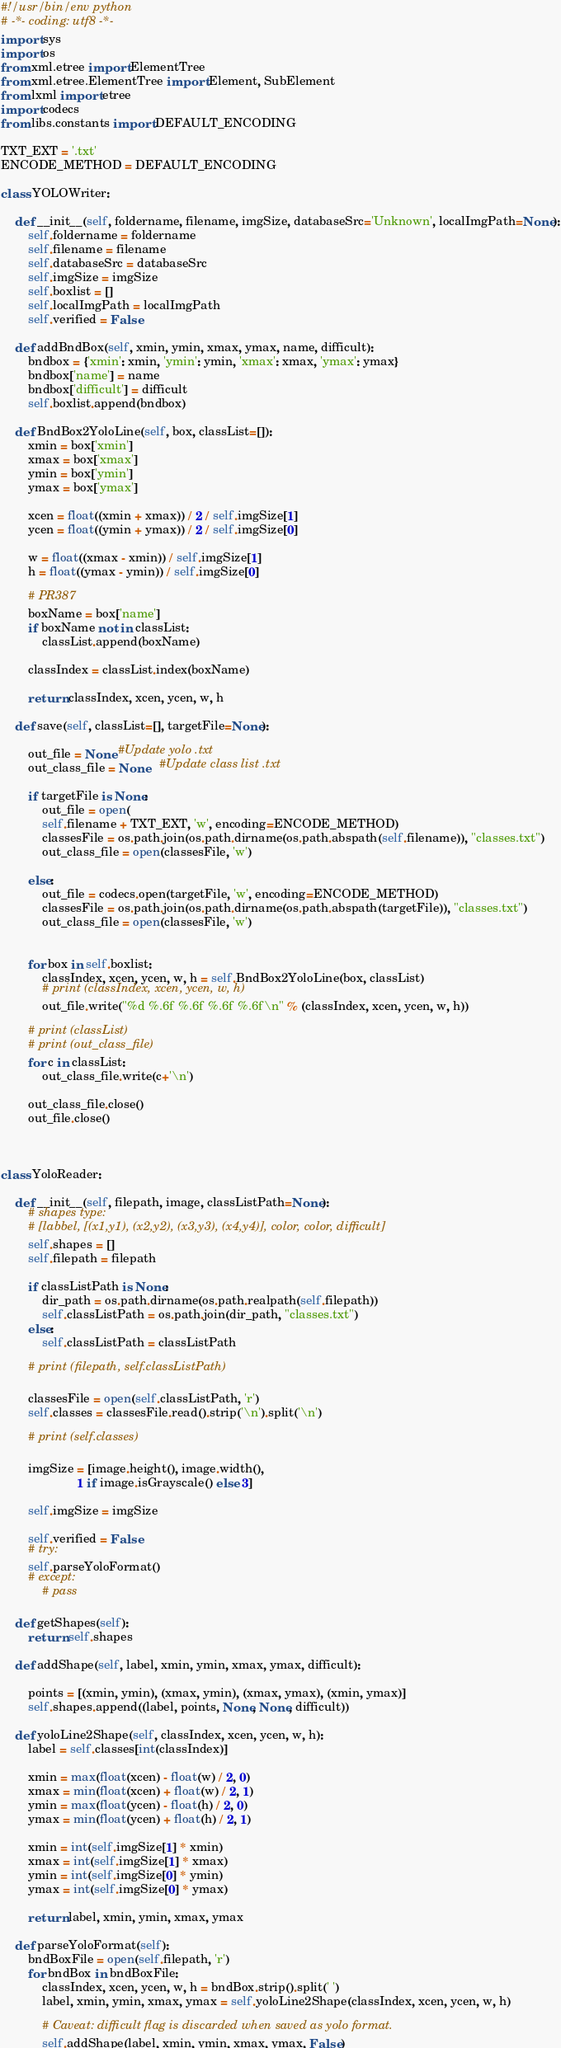Convert code to text. <code><loc_0><loc_0><loc_500><loc_500><_Python_>#!/usr/bin/env python
# -*- coding: utf8 -*-
import sys
import os
from xml.etree import ElementTree
from xml.etree.ElementTree import Element, SubElement
from lxml import etree
import codecs
from libs.constants import DEFAULT_ENCODING

TXT_EXT = '.txt'
ENCODE_METHOD = DEFAULT_ENCODING

class YOLOWriter:

    def __init__(self, foldername, filename, imgSize, databaseSrc='Unknown', localImgPath=None):
        self.foldername = foldername
        self.filename = filename
        self.databaseSrc = databaseSrc
        self.imgSize = imgSize
        self.boxlist = []
        self.localImgPath = localImgPath
        self.verified = False

    def addBndBox(self, xmin, ymin, xmax, ymax, name, difficult):
        bndbox = {'xmin': xmin, 'ymin': ymin, 'xmax': xmax, 'ymax': ymax}
        bndbox['name'] = name
        bndbox['difficult'] = difficult
        self.boxlist.append(bndbox)

    def BndBox2YoloLine(self, box, classList=[]):
        xmin = box['xmin']
        xmax = box['xmax']
        ymin = box['ymin']
        ymax = box['ymax']

        xcen = float((xmin + xmax)) / 2 / self.imgSize[1]
        ycen = float((ymin + ymax)) / 2 / self.imgSize[0]

        w = float((xmax - xmin)) / self.imgSize[1]
        h = float((ymax - ymin)) / self.imgSize[0]

        # PR387
        boxName = box['name']
        if boxName not in classList:
            classList.append(boxName)

        classIndex = classList.index(boxName)

        return classIndex, xcen, ycen, w, h

    def save(self, classList=[], targetFile=None):

        out_file = None #Update yolo .txt
        out_class_file = None   #Update class list .txt

        if targetFile is None:
            out_file = open(
            self.filename + TXT_EXT, 'w', encoding=ENCODE_METHOD)
            classesFile = os.path.join(os.path.dirname(os.path.abspath(self.filename)), "classes.txt")
            out_class_file = open(classesFile, 'w')

        else:
            out_file = codecs.open(targetFile, 'w', encoding=ENCODE_METHOD)
            classesFile = os.path.join(os.path.dirname(os.path.abspath(targetFile)), "classes.txt")
            out_class_file = open(classesFile, 'w')


        for box in self.boxlist:
            classIndex, xcen, ycen, w, h = self.BndBox2YoloLine(box, classList)
            # print (classIndex, xcen, ycen, w, h)
            out_file.write("%d %.6f %.6f %.6f %.6f\n" % (classIndex, xcen, ycen, w, h))

        # print (classList)
        # print (out_class_file)
        for c in classList:
            out_class_file.write(c+'\n')

        out_class_file.close()
        out_file.close()



class YoloReader:

    def __init__(self, filepath, image, classListPath=None):
        # shapes type:
        # [labbel, [(x1,y1), (x2,y2), (x3,y3), (x4,y4)], color, color, difficult]
        self.shapes = []
        self.filepath = filepath

        if classListPath is None:
            dir_path = os.path.dirname(os.path.realpath(self.filepath))
            self.classListPath = os.path.join(dir_path, "classes.txt")
        else:
            self.classListPath = classListPath

        # print (filepath, self.classListPath)

        classesFile = open(self.classListPath, 'r')
        self.classes = classesFile.read().strip('\n').split('\n')

        # print (self.classes)

        imgSize = [image.height(), image.width(),
                      1 if image.isGrayscale() else 3]

        self.imgSize = imgSize

        self.verified = False
        # try:
        self.parseYoloFormat()
        # except:
            # pass

    def getShapes(self):
        return self.shapes

    def addShape(self, label, xmin, ymin, xmax, ymax, difficult):

        points = [(xmin, ymin), (xmax, ymin), (xmax, ymax), (xmin, ymax)]
        self.shapes.append((label, points, None, None, difficult))

    def yoloLine2Shape(self, classIndex, xcen, ycen, w, h):
        label = self.classes[int(classIndex)]

        xmin = max(float(xcen) - float(w) / 2, 0)
        xmax = min(float(xcen) + float(w) / 2, 1)
        ymin = max(float(ycen) - float(h) / 2, 0)
        ymax = min(float(ycen) + float(h) / 2, 1)

        xmin = int(self.imgSize[1] * xmin)
        xmax = int(self.imgSize[1] * xmax)
        ymin = int(self.imgSize[0] * ymin)
        ymax = int(self.imgSize[0] * ymax)

        return label, xmin, ymin, xmax, ymax

    def parseYoloFormat(self):
        bndBoxFile = open(self.filepath, 'r')
        for bndBox in bndBoxFile:
            classIndex, xcen, ycen, w, h = bndBox.strip().split(' ')
            label, xmin, ymin, xmax, ymax = self.yoloLine2Shape(classIndex, xcen, ycen, w, h)

            # Caveat: difficult flag is discarded when saved as yolo format.
            self.addShape(label, xmin, ymin, xmax, ymax, False)
</code> 